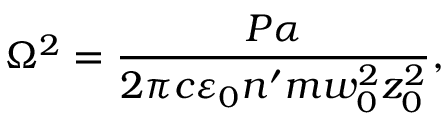<formula> <loc_0><loc_0><loc_500><loc_500>\Omega ^ { 2 } = \frac { P \alpha } { 2 \pi c \varepsilon _ { 0 } n ^ { \prime } m w _ { 0 } ^ { 2 } z _ { 0 } ^ { 2 } } ,</formula> 